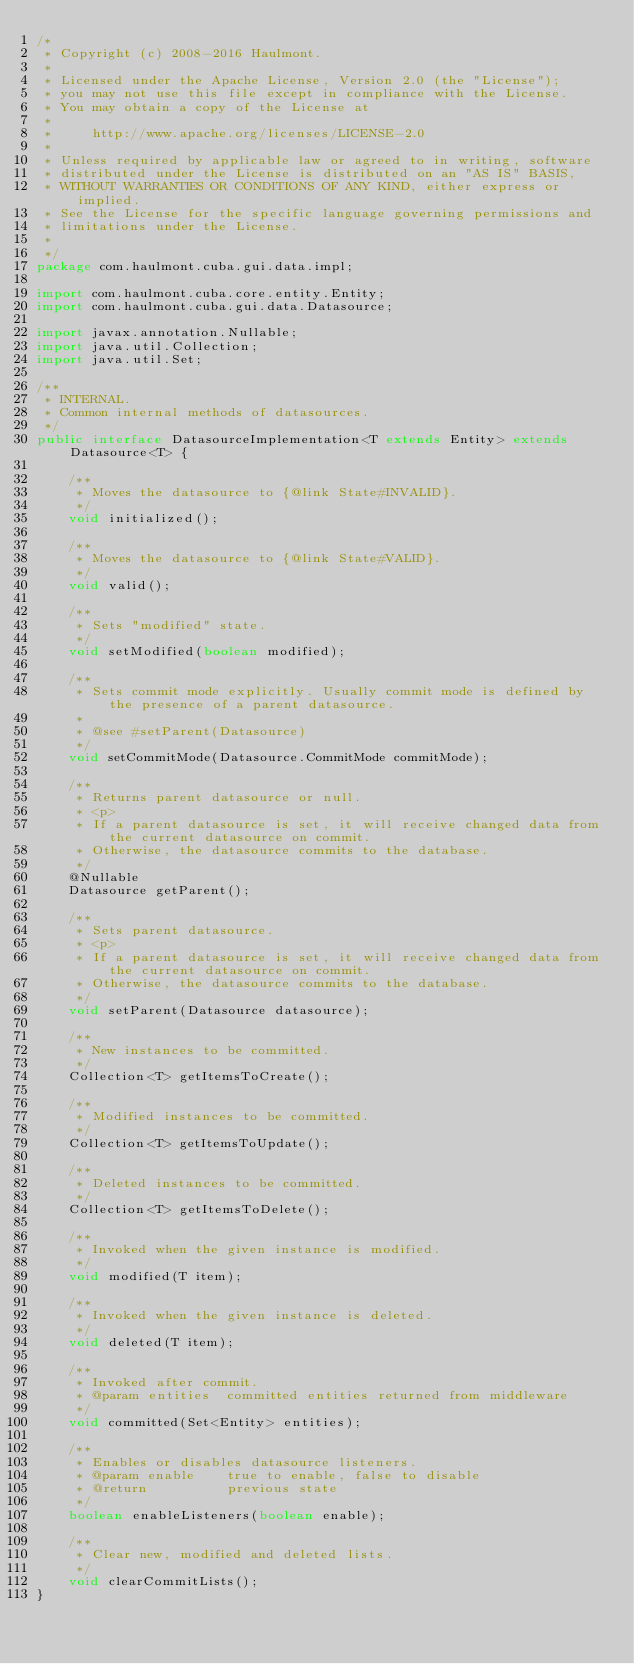<code> <loc_0><loc_0><loc_500><loc_500><_Java_>/*
 * Copyright (c) 2008-2016 Haulmont.
 *
 * Licensed under the Apache License, Version 2.0 (the "License");
 * you may not use this file except in compliance with the License.
 * You may obtain a copy of the License at
 *
 *     http://www.apache.org/licenses/LICENSE-2.0
 *
 * Unless required by applicable law or agreed to in writing, software
 * distributed under the License is distributed on an "AS IS" BASIS,
 * WITHOUT WARRANTIES OR CONDITIONS OF ANY KIND, either express or implied.
 * See the License for the specific language governing permissions and
 * limitations under the License.
 *
 */
package com.haulmont.cuba.gui.data.impl;

import com.haulmont.cuba.core.entity.Entity;
import com.haulmont.cuba.gui.data.Datasource;

import javax.annotation.Nullable;
import java.util.Collection;
import java.util.Set;

/**
 * INTERNAL.
 * Common internal methods of datasources.
 */
public interface DatasourceImplementation<T extends Entity> extends Datasource<T> {

    /**
     * Moves the datasource to {@link State#INVALID}.
     */
    void initialized();

    /**
     * Moves the datasource to {@link State#VALID}.
     */
    void valid();

    /**
     * Sets "modified" state.
     */
    void setModified(boolean modified);

    /**
     * Sets commit mode explicitly. Usually commit mode is defined by the presence of a parent datasource.
     *
     * @see #setParent(Datasource)
     */
    void setCommitMode(Datasource.CommitMode commitMode);

    /**
     * Returns parent datasource or null.
     * <p>
     * If a parent datasource is set, it will receive changed data from the current datasource on commit.
     * Otherwise, the datasource commits to the database.
     */
    @Nullable
    Datasource getParent();

    /**
     * Sets parent datasource.
     * <p>
     * If a parent datasource is set, it will receive changed data from the current datasource on commit.
     * Otherwise, the datasource commits to the database.
     */
    void setParent(Datasource datasource);

    /**
     * New instances to be committed.
     */
    Collection<T> getItemsToCreate();

    /**
     * Modified instances to be committed.
     */
    Collection<T> getItemsToUpdate();

    /**
     * Deleted instances to be committed.
     */
    Collection<T> getItemsToDelete();

    /**
     * Invoked when the given instance is modified.
     */
    void modified(T item);

    /**
     * Invoked when the given instance is deleted.
     */
    void deleted(T item);

    /**
     * Invoked after commit.
     * @param entities  committed entities returned from middleware
     */
    void committed(Set<Entity> entities);

    /**
     * Enables or disables datasource listeners.
     * @param enable    true to enable, false to disable
     * @return          previous state
     */
    boolean enableListeners(boolean enable);

    /**
     * Clear new, modified and deleted lists.
     */
    void clearCommitLists();
}</code> 